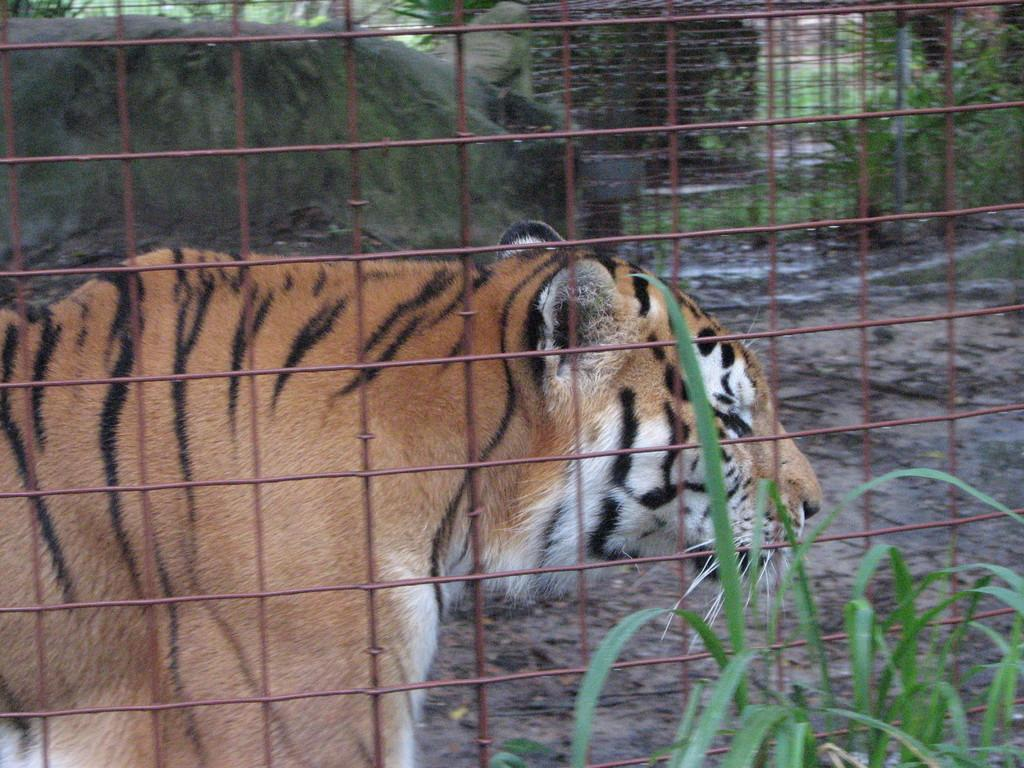What type of living organism can be seen in the image? There is a plant in the image. What is the material of the mesh in the image? There is a mesh in the image. What animal is behind the mesh? There is a tiger behind the mesh. What else can be seen behind the mesh? There are plants visible behind the mesh. What type of hat is the tiger wearing in the image? There is no hat present in the image; the tiger is behind the mesh. Can you describe the hill in the background of the image? There is no hill visible in the image; it features a plant, mesh, tiger, and plants behind the mesh. 